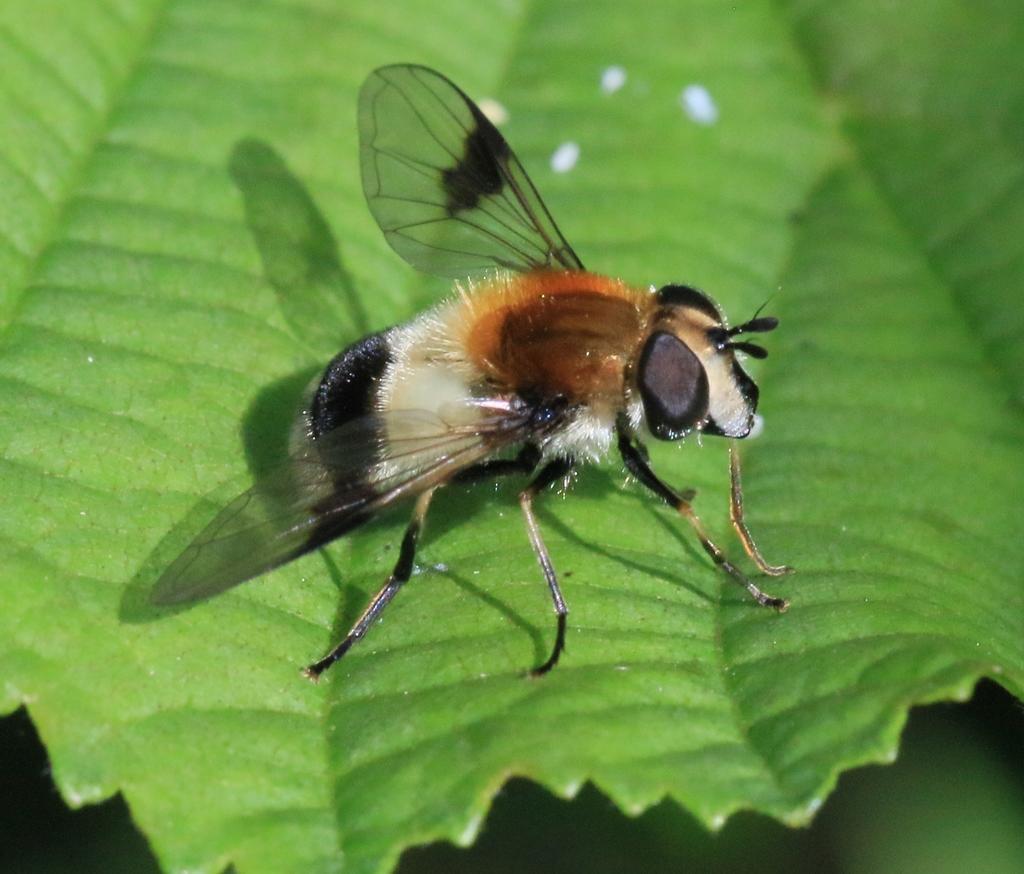How would you summarize this image in a sentence or two? In the image we can see a leaf, on the leaf there is an insect. The insect is black, silver and light brown in color. 